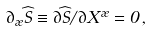Convert formula to latex. <formula><loc_0><loc_0><loc_500><loc_500>\partial _ { \rho } \widehat { S } \equiv \partial \widehat { S } / \partial X ^ { \rho } = 0 \, ,</formula> 